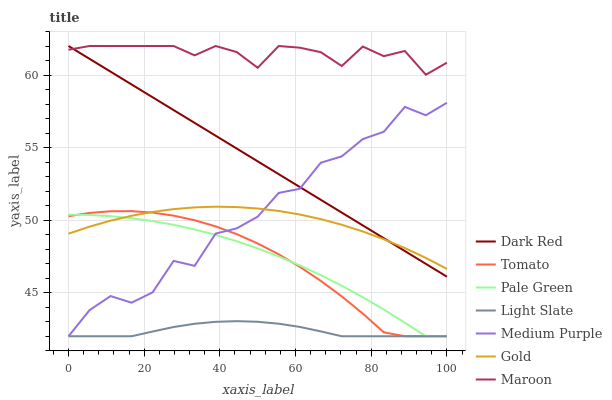Does Gold have the minimum area under the curve?
Answer yes or no. No. Does Gold have the maximum area under the curve?
Answer yes or no. No. Is Gold the smoothest?
Answer yes or no. No. Is Gold the roughest?
Answer yes or no. No. Does Gold have the lowest value?
Answer yes or no. No. Does Gold have the highest value?
Answer yes or no. No. Is Light Slate less than Gold?
Answer yes or no. Yes. Is Dark Red greater than Tomato?
Answer yes or no. Yes. Does Light Slate intersect Gold?
Answer yes or no. No. 